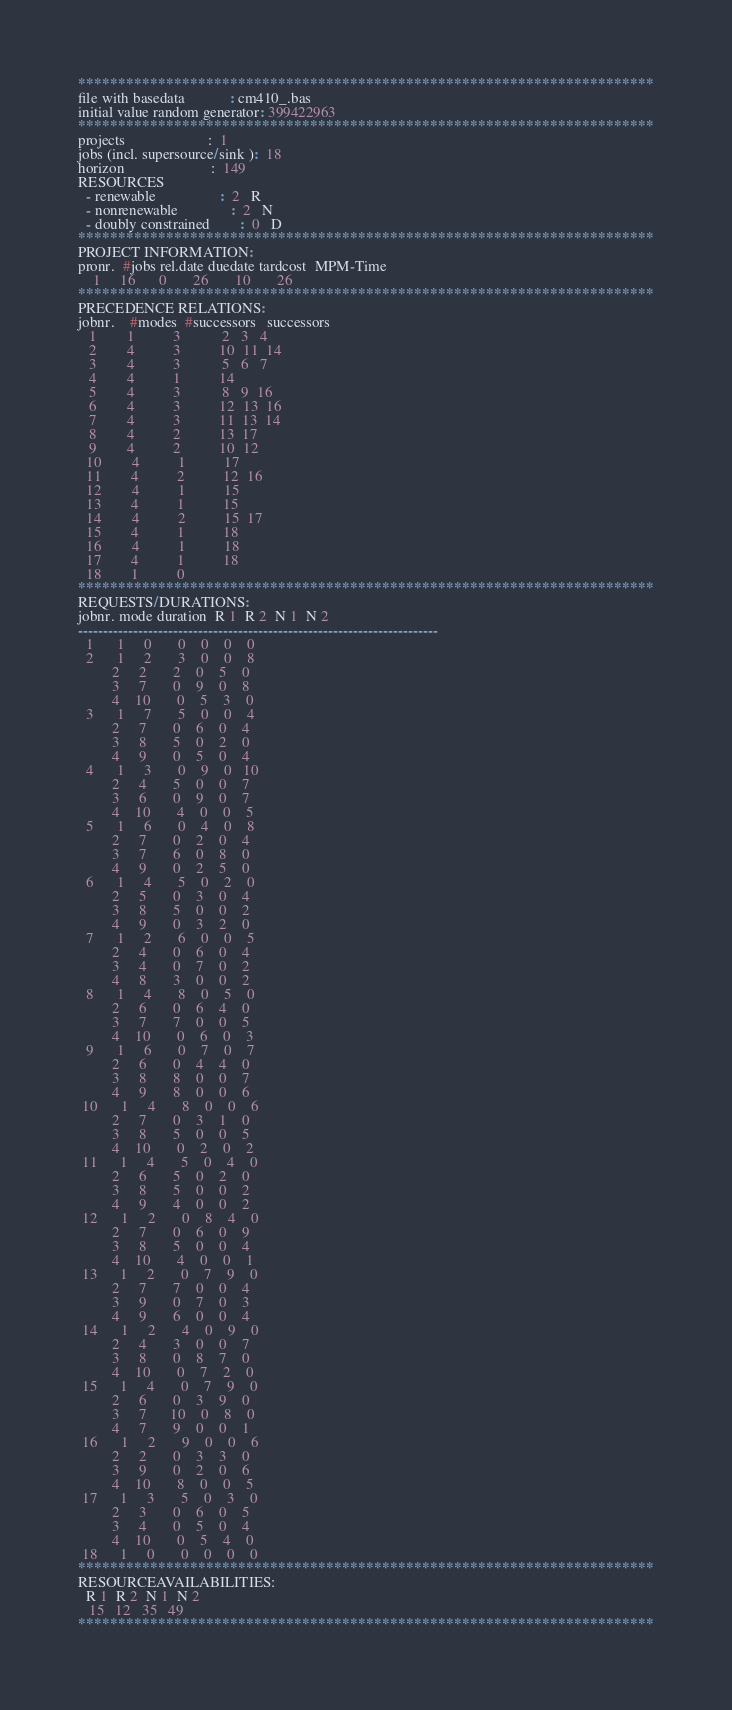<code> <loc_0><loc_0><loc_500><loc_500><_ObjectiveC_>************************************************************************
file with basedata            : cm410_.bas
initial value random generator: 399422963
************************************************************************
projects                      :  1
jobs (incl. supersource/sink ):  18
horizon                       :  149
RESOURCES
  - renewable                 :  2   R
  - nonrenewable              :  2   N
  - doubly constrained        :  0   D
************************************************************************
PROJECT INFORMATION:
pronr.  #jobs rel.date duedate tardcost  MPM-Time
    1     16      0       26       10       26
************************************************************************
PRECEDENCE RELATIONS:
jobnr.    #modes  #successors   successors
   1        1          3           2   3   4
   2        4          3          10  11  14
   3        4          3           5   6   7
   4        4          1          14
   5        4          3           8   9  16
   6        4          3          12  13  16
   7        4          3          11  13  14
   8        4          2          13  17
   9        4          2          10  12
  10        4          1          17
  11        4          2          12  16
  12        4          1          15
  13        4          1          15
  14        4          2          15  17
  15        4          1          18
  16        4          1          18
  17        4          1          18
  18        1          0        
************************************************************************
REQUESTS/DURATIONS:
jobnr. mode duration  R 1  R 2  N 1  N 2
------------------------------------------------------------------------
  1      1     0       0    0    0    0
  2      1     2       3    0    0    8
         2     2       2    0    5    0
         3     7       0    9    0    8
         4    10       0    5    3    0
  3      1     7       5    0    0    4
         2     7       0    6    0    4
         3     8       5    0    2    0
         4     9       0    5    0    4
  4      1     3       0    9    0   10
         2     4       5    0    0    7
         3     6       0    9    0    7
         4    10       4    0    0    5
  5      1     6       0    4    0    8
         2     7       0    2    0    4
         3     7       6    0    8    0
         4     9       0    2    5    0
  6      1     4       5    0    2    0
         2     5       0    3    0    4
         3     8       5    0    0    2
         4     9       0    3    2    0
  7      1     2       6    0    0    5
         2     4       0    6    0    4
         3     4       0    7    0    2
         4     8       3    0    0    2
  8      1     4       8    0    5    0
         2     6       0    6    4    0
         3     7       7    0    0    5
         4    10       0    6    0    3
  9      1     6       0    7    0    7
         2     6       0    4    4    0
         3     8       8    0    0    7
         4     9       8    0    0    6
 10      1     4       8    0    0    6
         2     7       0    3    1    0
         3     8       5    0    0    5
         4    10       0    2    0    2
 11      1     4       5    0    4    0
         2     6       5    0    2    0
         3     8       5    0    0    2
         4     9       4    0    0    2
 12      1     2       0    8    4    0
         2     7       0    6    0    9
         3     8       5    0    0    4
         4    10       4    0    0    1
 13      1     2       0    7    9    0
         2     7       7    0    0    4
         3     9       0    7    0    3
         4     9       6    0    0    4
 14      1     2       4    0    9    0
         2     4       3    0    0    7
         3     8       0    8    7    0
         4    10       0    7    2    0
 15      1     4       0    7    9    0
         2     6       0    3    9    0
         3     7      10    0    8    0
         4     7       9    0    0    1
 16      1     2       9    0    0    6
         2     2       0    3    3    0
         3     9       0    2    0    6
         4    10       8    0    0    5
 17      1     3       5    0    3    0
         2     3       0    6    0    5
         3     4       0    5    0    4
         4    10       0    5    4    0
 18      1     0       0    0    0    0
************************************************************************
RESOURCEAVAILABILITIES:
  R 1  R 2  N 1  N 2
   15   12   35   49
************************************************************************
</code> 